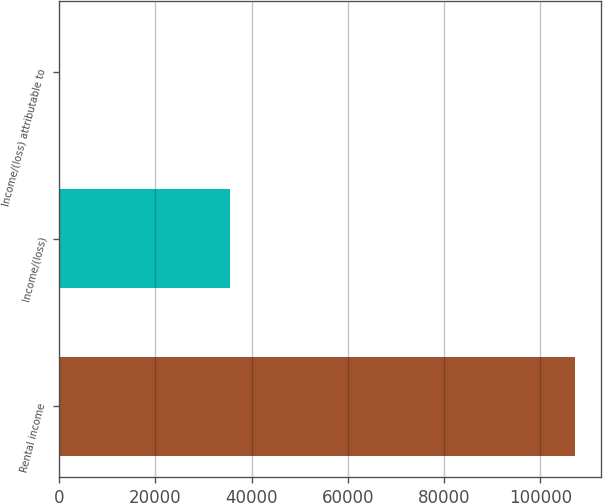Convert chart. <chart><loc_0><loc_0><loc_500><loc_500><bar_chart><fcel>Rental income<fcel>Income/(loss)<fcel>Income/(loss) attributable to<nl><fcel>107266<fcel>35487.6<fcel>0.13<nl></chart> 